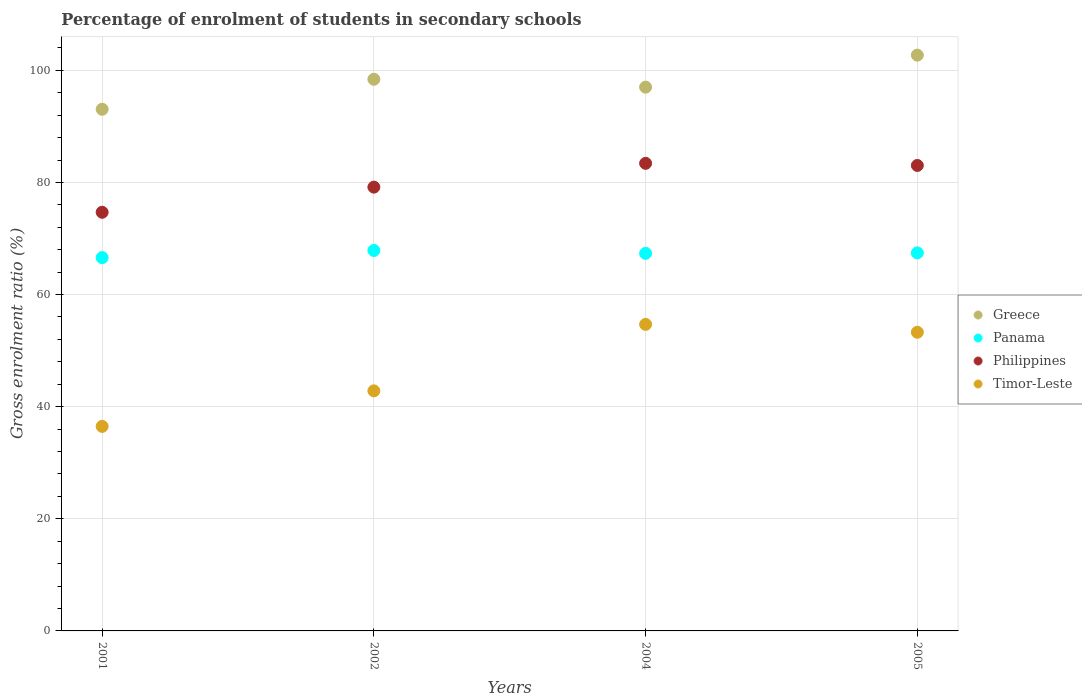What is the percentage of students enrolled in secondary schools in Greece in 2004?
Give a very brief answer. 97. Across all years, what is the maximum percentage of students enrolled in secondary schools in Timor-Leste?
Provide a succinct answer. 54.68. Across all years, what is the minimum percentage of students enrolled in secondary schools in Philippines?
Offer a terse response. 74.68. What is the total percentage of students enrolled in secondary schools in Philippines in the graph?
Offer a very short reply. 320.27. What is the difference between the percentage of students enrolled in secondary schools in Panama in 2001 and that in 2002?
Offer a terse response. -1.27. What is the difference between the percentage of students enrolled in secondary schools in Panama in 2002 and the percentage of students enrolled in secondary schools in Philippines in 2005?
Make the answer very short. -15.17. What is the average percentage of students enrolled in secondary schools in Panama per year?
Offer a very short reply. 67.31. In the year 2002, what is the difference between the percentage of students enrolled in secondary schools in Timor-Leste and percentage of students enrolled in secondary schools in Philippines?
Your answer should be compact. -36.34. In how many years, is the percentage of students enrolled in secondary schools in Greece greater than 96 %?
Your response must be concise. 3. What is the ratio of the percentage of students enrolled in secondary schools in Panama in 2002 to that in 2005?
Ensure brevity in your answer.  1.01. Is the percentage of students enrolled in secondary schools in Philippines in 2001 less than that in 2002?
Offer a very short reply. Yes. Is the difference between the percentage of students enrolled in secondary schools in Timor-Leste in 2001 and 2002 greater than the difference between the percentage of students enrolled in secondary schools in Philippines in 2001 and 2002?
Your answer should be very brief. No. What is the difference between the highest and the second highest percentage of students enrolled in secondary schools in Panama?
Offer a terse response. 0.43. What is the difference between the highest and the lowest percentage of students enrolled in secondary schools in Panama?
Your answer should be compact. 1.27. Is the sum of the percentage of students enrolled in secondary schools in Timor-Leste in 2002 and 2005 greater than the maximum percentage of students enrolled in secondary schools in Panama across all years?
Ensure brevity in your answer.  Yes. Is it the case that in every year, the sum of the percentage of students enrolled in secondary schools in Timor-Leste and percentage of students enrolled in secondary schools in Panama  is greater than the sum of percentage of students enrolled in secondary schools in Greece and percentage of students enrolled in secondary schools in Philippines?
Make the answer very short. No. Does the percentage of students enrolled in secondary schools in Greece monotonically increase over the years?
Provide a short and direct response. No. Is the percentage of students enrolled in secondary schools in Philippines strictly less than the percentage of students enrolled in secondary schools in Panama over the years?
Make the answer very short. No. How many years are there in the graph?
Make the answer very short. 4. Are the values on the major ticks of Y-axis written in scientific E-notation?
Make the answer very short. No. How many legend labels are there?
Keep it short and to the point. 4. How are the legend labels stacked?
Keep it short and to the point. Vertical. What is the title of the graph?
Your answer should be compact. Percentage of enrolment of students in secondary schools. What is the label or title of the X-axis?
Your response must be concise. Years. What is the Gross enrolment ratio (%) of Greece in 2001?
Keep it short and to the point. 93.05. What is the Gross enrolment ratio (%) in Panama in 2001?
Provide a succinct answer. 66.59. What is the Gross enrolment ratio (%) in Philippines in 2001?
Provide a short and direct response. 74.68. What is the Gross enrolment ratio (%) of Timor-Leste in 2001?
Make the answer very short. 36.48. What is the Gross enrolment ratio (%) in Greece in 2002?
Offer a very short reply. 98.4. What is the Gross enrolment ratio (%) in Panama in 2002?
Provide a short and direct response. 67.86. What is the Gross enrolment ratio (%) of Philippines in 2002?
Ensure brevity in your answer.  79.16. What is the Gross enrolment ratio (%) of Timor-Leste in 2002?
Your response must be concise. 42.82. What is the Gross enrolment ratio (%) of Greece in 2004?
Your answer should be very brief. 97. What is the Gross enrolment ratio (%) in Panama in 2004?
Your response must be concise. 67.35. What is the Gross enrolment ratio (%) of Philippines in 2004?
Provide a short and direct response. 83.41. What is the Gross enrolment ratio (%) in Timor-Leste in 2004?
Your response must be concise. 54.68. What is the Gross enrolment ratio (%) of Greece in 2005?
Offer a very short reply. 102.71. What is the Gross enrolment ratio (%) in Panama in 2005?
Offer a very short reply. 67.43. What is the Gross enrolment ratio (%) of Philippines in 2005?
Ensure brevity in your answer.  83.03. What is the Gross enrolment ratio (%) of Timor-Leste in 2005?
Provide a succinct answer. 53.27. Across all years, what is the maximum Gross enrolment ratio (%) in Greece?
Make the answer very short. 102.71. Across all years, what is the maximum Gross enrolment ratio (%) in Panama?
Provide a short and direct response. 67.86. Across all years, what is the maximum Gross enrolment ratio (%) in Philippines?
Provide a succinct answer. 83.41. Across all years, what is the maximum Gross enrolment ratio (%) of Timor-Leste?
Offer a terse response. 54.68. Across all years, what is the minimum Gross enrolment ratio (%) of Greece?
Offer a very short reply. 93.05. Across all years, what is the minimum Gross enrolment ratio (%) in Panama?
Make the answer very short. 66.59. Across all years, what is the minimum Gross enrolment ratio (%) of Philippines?
Make the answer very short. 74.68. Across all years, what is the minimum Gross enrolment ratio (%) of Timor-Leste?
Your answer should be compact. 36.48. What is the total Gross enrolment ratio (%) of Greece in the graph?
Your answer should be very brief. 391.15. What is the total Gross enrolment ratio (%) of Panama in the graph?
Your answer should be compact. 269.23. What is the total Gross enrolment ratio (%) in Philippines in the graph?
Offer a terse response. 320.27. What is the total Gross enrolment ratio (%) in Timor-Leste in the graph?
Keep it short and to the point. 187.25. What is the difference between the Gross enrolment ratio (%) in Greece in 2001 and that in 2002?
Provide a short and direct response. -5.35. What is the difference between the Gross enrolment ratio (%) of Panama in 2001 and that in 2002?
Offer a very short reply. -1.27. What is the difference between the Gross enrolment ratio (%) of Philippines in 2001 and that in 2002?
Give a very brief answer. -4.48. What is the difference between the Gross enrolment ratio (%) in Timor-Leste in 2001 and that in 2002?
Your answer should be compact. -6.34. What is the difference between the Gross enrolment ratio (%) in Greece in 2001 and that in 2004?
Ensure brevity in your answer.  -3.95. What is the difference between the Gross enrolment ratio (%) of Panama in 2001 and that in 2004?
Make the answer very short. -0.76. What is the difference between the Gross enrolment ratio (%) in Philippines in 2001 and that in 2004?
Provide a succinct answer. -8.73. What is the difference between the Gross enrolment ratio (%) of Timor-Leste in 2001 and that in 2004?
Offer a very short reply. -18.2. What is the difference between the Gross enrolment ratio (%) of Greece in 2001 and that in 2005?
Provide a short and direct response. -9.66. What is the difference between the Gross enrolment ratio (%) in Panama in 2001 and that in 2005?
Offer a terse response. -0.84. What is the difference between the Gross enrolment ratio (%) in Philippines in 2001 and that in 2005?
Your answer should be very brief. -8.35. What is the difference between the Gross enrolment ratio (%) in Timor-Leste in 2001 and that in 2005?
Offer a very short reply. -16.79. What is the difference between the Gross enrolment ratio (%) of Greece in 2002 and that in 2004?
Keep it short and to the point. 1.41. What is the difference between the Gross enrolment ratio (%) of Panama in 2002 and that in 2004?
Your answer should be very brief. 0.51. What is the difference between the Gross enrolment ratio (%) in Philippines in 2002 and that in 2004?
Ensure brevity in your answer.  -4.25. What is the difference between the Gross enrolment ratio (%) of Timor-Leste in 2002 and that in 2004?
Provide a short and direct response. -11.86. What is the difference between the Gross enrolment ratio (%) in Greece in 2002 and that in 2005?
Keep it short and to the point. -4.3. What is the difference between the Gross enrolment ratio (%) in Panama in 2002 and that in 2005?
Offer a very short reply. 0.43. What is the difference between the Gross enrolment ratio (%) in Philippines in 2002 and that in 2005?
Offer a terse response. -3.87. What is the difference between the Gross enrolment ratio (%) in Timor-Leste in 2002 and that in 2005?
Offer a very short reply. -10.45. What is the difference between the Gross enrolment ratio (%) of Greece in 2004 and that in 2005?
Your answer should be compact. -5.71. What is the difference between the Gross enrolment ratio (%) of Panama in 2004 and that in 2005?
Give a very brief answer. -0.08. What is the difference between the Gross enrolment ratio (%) in Philippines in 2004 and that in 2005?
Offer a terse response. 0.38. What is the difference between the Gross enrolment ratio (%) of Timor-Leste in 2004 and that in 2005?
Ensure brevity in your answer.  1.41. What is the difference between the Gross enrolment ratio (%) in Greece in 2001 and the Gross enrolment ratio (%) in Panama in 2002?
Provide a succinct answer. 25.19. What is the difference between the Gross enrolment ratio (%) of Greece in 2001 and the Gross enrolment ratio (%) of Philippines in 2002?
Ensure brevity in your answer.  13.89. What is the difference between the Gross enrolment ratio (%) of Greece in 2001 and the Gross enrolment ratio (%) of Timor-Leste in 2002?
Provide a succinct answer. 50.23. What is the difference between the Gross enrolment ratio (%) in Panama in 2001 and the Gross enrolment ratio (%) in Philippines in 2002?
Your answer should be very brief. -12.57. What is the difference between the Gross enrolment ratio (%) in Panama in 2001 and the Gross enrolment ratio (%) in Timor-Leste in 2002?
Provide a succinct answer. 23.77. What is the difference between the Gross enrolment ratio (%) of Philippines in 2001 and the Gross enrolment ratio (%) of Timor-Leste in 2002?
Give a very brief answer. 31.86. What is the difference between the Gross enrolment ratio (%) of Greece in 2001 and the Gross enrolment ratio (%) of Panama in 2004?
Offer a very short reply. 25.7. What is the difference between the Gross enrolment ratio (%) of Greece in 2001 and the Gross enrolment ratio (%) of Philippines in 2004?
Offer a very short reply. 9.64. What is the difference between the Gross enrolment ratio (%) of Greece in 2001 and the Gross enrolment ratio (%) of Timor-Leste in 2004?
Provide a short and direct response. 38.37. What is the difference between the Gross enrolment ratio (%) in Panama in 2001 and the Gross enrolment ratio (%) in Philippines in 2004?
Provide a succinct answer. -16.82. What is the difference between the Gross enrolment ratio (%) of Panama in 2001 and the Gross enrolment ratio (%) of Timor-Leste in 2004?
Your response must be concise. 11.91. What is the difference between the Gross enrolment ratio (%) in Philippines in 2001 and the Gross enrolment ratio (%) in Timor-Leste in 2004?
Offer a very short reply. 20. What is the difference between the Gross enrolment ratio (%) of Greece in 2001 and the Gross enrolment ratio (%) of Panama in 2005?
Ensure brevity in your answer.  25.61. What is the difference between the Gross enrolment ratio (%) in Greece in 2001 and the Gross enrolment ratio (%) in Philippines in 2005?
Ensure brevity in your answer.  10.02. What is the difference between the Gross enrolment ratio (%) in Greece in 2001 and the Gross enrolment ratio (%) in Timor-Leste in 2005?
Make the answer very short. 39.78. What is the difference between the Gross enrolment ratio (%) of Panama in 2001 and the Gross enrolment ratio (%) of Philippines in 2005?
Offer a terse response. -16.44. What is the difference between the Gross enrolment ratio (%) of Panama in 2001 and the Gross enrolment ratio (%) of Timor-Leste in 2005?
Your answer should be compact. 13.32. What is the difference between the Gross enrolment ratio (%) of Philippines in 2001 and the Gross enrolment ratio (%) of Timor-Leste in 2005?
Provide a succinct answer. 21.41. What is the difference between the Gross enrolment ratio (%) of Greece in 2002 and the Gross enrolment ratio (%) of Panama in 2004?
Your answer should be compact. 31.05. What is the difference between the Gross enrolment ratio (%) of Greece in 2002 and the Gross enrolment ratio (%) of Philippines in 2004?
Keep it short and to the point. 14.99. What is the difference between the Gross enrolment ratio (%) of Greece in 2002 and the Gross enrolment ratio (%) of Timor-Leste in 2004?
Offer a terse response. 43.72. What is the difference between the Gross enrolment ratio (%) of Panama in 2002 and the Gross enrolment ratio (%) of Philippines in 2004?
Your response must be concise. -15.55. What is the difference between the Gross enrolment ratio (%) in Panama in 2002 and the Gross enrolment ratio (%) in Timor-Leste in 2004?
Make the answer very short. 13.18. What is the difference between the Gross enrolment ratio (%) in Philippines in 2002 and the Gross enrolment ratio (%) in Timor-Leste in 2004?
Offer a terse response. 24.48. What is the difference between the Gross enrolment ratio (%) in Greece in 2002 and the Gross enrolment ratio (%) in Panama in 2005?
Your response must be concise. 30.97. What is the difference between the Gross enrolment ratio (%) in Greece in 2002 and the Gross enrolment ratio (%) in Philippines in 2005?
Your answer should be compact. 15.37. What is the difference between the Gross enrolment ratio (%) of Greece in 2002 and the Gross enrolment ratio (%) of Timor-Leste in 2005?
Provide a short and direct response. 45.13. What is the difference between the Gross enrolment ratio (%) of Panama in 2002 and the Gross enrolment ratio (%) of Philippines in 2005?
Offer a terse response. -15.17. What is the difference between the Gross enrolment ratio (%) of Panama in 2002 and the Gross enrolment ratio (%) of Timor-Leste in 2005?
Your response must be concise. 14.59. What is the difference between the Gross enrolment ratio (%) of Philippines in 2002 and the Gross enrolment ratio (%) of Timor-Leste in 2005?
Your response must be concise. 25.89. What is the difference between the Gross enrolment ratio (%) of Greece in 2004 and the Gross enrolment ratio (%) of Panama in 2005?
Ensure brevity in your answer.  29.56. What is the difference between the Gross enrolment ratio (%) in Greece in 2004 and the Gross enrolment ratio (%) in Philippines in 2005?
Make the answer very short. 13.97. What is the difference between the Gross enrolment ratio (%) of Greece in 2004 and the Gross enrolment ratio (%) of Timor-Leste in 2005?
Give a very brief answer. 43.72. What is the difference between the Gross enrolment ratio (%) in Panama in 2004 and the Gross enrolment ratio (%) in Philippines in 2005?
Your response must be concise. -15.68. What is the difference between the Gross enrolment ratio (%) of Panama in 2004 and the Gross enrolment ratio (%) of Timor-Leste in 2005?
Ensure brevity in your answer.  14.08. What is the difference between the Gross enrolment ratio (%) in Philippines in 2004 and the Gross enrolment ratio (%) in Timor-Leste in 2005?
Provide a succinct answer. 30.14. What is the average Gross enrolment ratio (%) in Greece per year?
Make the answer very short. 97.79. What is the average Gross enrolment ratio (%) in Panama per year?
Give a very brief answer. 67.31. What is the average Gross enrolment ratio (%) in Philippines per year?
Ensure brevity in your answer.  80.07. What is the average Gross enrolment ratio (%) in Timor-Leste per year?
Ensure brevity in your answer.  46.81. In the year 2001, what is the difference between the Gross enrolment ratio (%) of Greece and Gross enrolment ratio (%) of Panama?
Your answer should be very brief. 26.46. In the year 2001, what is the difference between the Gross enrolment ratio (%) of Greece and Gross enrolment ratio (%) of Philippines?
Ensure brevity in your answer.  18.37. In the year 2001, what is the difference between the Gross enrolment ratio (%) in Greece and Gross enrolment ratio (%) in Timor-Leste?
Provide a short and direct response. 56.57. In the year 2001, what is the difference between the Gross enrolment ratio (%) of Panama and Gross enrolment ratio (%) of Philippines?
Provide a succinct answer. -8.09. In the year 2001, what is the difference between the Gross enrolment ratio (%) in Panama and Gross enrolment ratio (%) in Timor-Leste?
Offer a terse response. 30.11. In the year 2001, what is the difference between the Gross enrolment ratio (%) of Philippines and Gross enrolment ratio (%) of Timor-Leste?
Your response must be concise. 38.19. In the year 2002, what is the difference between the Gross enrolment ratio (%) of Greece and Gross enrolment ratio (%) of Panama?
Offer a terse response. 30.54. In the year 2002, what is the difference between the Gross enrolment ratio (%) in Greece and Gross enrolment ratio (%) in Philippines?
Provide a short and direct response. 19.24. In the year 2002, what is the difference between the Gross enrolment ratio (%) in Greece and Gross enrolment ratio (%) in Timor-Leste?
Offer a terse response. 55.58. In the year 2002, what is the difference between the Gross enrolment ratio (%) in Panama and Gross enrolment ratio (%) in Philippines?
Provide a succinct answer. -11.3. In the year 2002, what is the difference between the Gross enrolment ratio (%) of Panama and Gross enrolment ratio (%) of Timor-Leste?
Provide a short and direct response. 25.04. In the year 2002, what is the difference between the Gross enrolment ratio (%) in Philippines and Gross enrolment ratio (%) in Timor-Leste?
Ensure brevity in your answer.  36.34. In the year 2004, what is the difference between the Gross enrolment ratio (%) of Greece and Gross enrolment ratio (%) of Panama?
Provide a short and direct response. 29.65. In the year 2004, what is the difference between the Gross enrolment ratio (%) of Greece and Gross enrolment ratio (%) of Philippines?
Offer a terse response. 13.59. In the year 2004, what is the difference between the Gross enrolment ratio (%) of Greece and Gross enrolment ratio (%) of Timor-Leste?
Your response must be concise. 42.32. In the year 2004, what is the difference between the Gross enrolment ratio (%) in Panama and Gross enrolment ratio (%) in Philippines?
Give a very brief answer. -16.06. In the year 2004, what is the difference between the Gross enrolment ratio (%) of Panama and Gross enrolment ratio (%) of Timor-Leste?
Keep it short and to the point. 12.67. In the year 2004, what is the difference between the Gross enrolment ratio (%) in Philippines and Gross enrolment ratio (%) in Timor-Leste?
Ensure brevity in your answer.  28.73. In the year 2005, what is the difference between the Gross enrolment ratio (%) in Greece and Gross enrolment ratio (%) in Panama?
Keep it short and to the point. 35.27. In the year 2005, what is the difference between the Gross enrolment ratio (%) in Greece and Gross enrolment ratio (%) in Philippines?
Give a very brief answer. 19.68. In the year 2005, what is the difference between the Gross enrolment ratio (%) of Greece and Gross enrolment ratio (%) of Timor-Leste?
Make the answer very short. 49.43. In the year 2005, what is the difference between the Gross enrolment ratio (%) in Panama and Gross enrolment ratio (%) in Philippines?
Offer a terse response. -15.59. In the year 2005, what is the difference between the Gross enrolment ratio (%) in Panama and Gross enrolment ratio (%) in Timor-Leste?
Your response must be concise. 14.16. In the year 2005, what is the difference between the Gross enrolment ratio (%) in Philippines and Gross enrolment ratio (%) in Timor-Leste?
Provide a succinct answer. 29.76. What is the ratio of the Gross enrolment ratio (%) in Greece in 2001 to that in 2002?
Make the answer very short. 0.95. What is the ratio of the Gross enrolment ratio (%) in Panama in 2001 to that in 2002?
Offer a terse response. 0.98. What is the ratio of the Gross enrolment ratio (%) in Philippines in 2001 to that in 2002?
Provide a short and direct response. 0.94. What is the ratio of the Gross enrolment ratio (%) in Timor-Leste in 2001 to that in 2002?
Your answer should be compact. 0.85. What is the ratio of the Gross enrolment ratio (%) of Greece in 2001 to that in 2004?
Offer a terse response. 0.96. What is the ratio of the Gross enrolment ratio (%) of Panama in 2001 to that in 2004?
Keep it short and to the point. 0.99. What is the ratio of the Gross enrolment ratio (%) in Philippines in 2001 to that in 2004?
Make the answer very short. 0.9. What is the ratio of the Gross enrolment ratio (%) of Timor-Leste in 2001 to that in 2004?
Provide a short and direct response. 0.67. What is the ratio of the Gross enrolment ratio (%) in Greece in 2001 to that in 2005?
Ensure brevity in your answer.  0.91. What is the ratio of the Gross enrolment ratio (%) in Panama in 2001 to that in 2005?
Provide a short and direct response. 0.99. What is the ratio of the Gross enrolment ratio (%) in Philippines in 2001 to that in 2005?
Offer a terse response. 0.9. What is the ratio of the Gross enrolment ratio (%) in Timor-Leste in 2001 to that in 2005?
Offer a terse response. 0.68. What is the ratio of the Gross enrolment ratio (%) in Greece in 2002 to that in 2004?
Give a very brief answer. 1.01. What is the ratio of the Gross enrolment ratio (%) of Panama in 2002 to that in 2004?
Make the answer very short. 1.01. What is the ratio of the Gross enrolment ratio (%) in Philippines in 2002 to that in 2004?
Provide a short and direct response. 0.95. What is the ratio of the Gross enrolment ratio (%) of Timor-Leste in 2002 to that in 2004?
Your response must be concise. 0.78. What is the ratio of the Gross enrolment ratio (%) of Greece in 2002 to that in 2005?
Make the answer very short. 0.96. What is the ratio of the Gross enrolment ratio (%) in Philippines in 2002 to that in 2005?
Give a very brief answer. 0.95. What is the ratio of the Gross enrolment ratio (%) in Timor-Leste in 2002 to that in 2005?
Your answer should be compact. 0.8. What is the ratio of the Gross enrolment ratio (%) of Timor-Leste in 2004 to that in 2005?
Give a very brief answer. 1.03. What is the difference between the highest and the second highest Gross enrolment ratio (%) of Greece?
Your response must be concise. 4.3. What is the difference between the highest and the second highest Gross enrolment ratio (%) in Panama?
Your response must be concise. 0.43. What is the difference between the highest and the second highest Gross enrolment ratio (%) of Philippines?
Provide a succinct answer. 0.38. What is the difference between the highest and the second highest Gross enrolment ratio (%) in Timor-Leste?
Give a very brief answer. 1.41. What is the difference between the highest and the lowest Gross enrolment ratio (%) of Greece?
Provide a succinct answer. 9.66. What is the difference between the highest and the lowest Gross enrolment ratio (%) of Panama?
Give a very brief answer. 1.27. What is the difference between the highest and the lowest Gross enrolment ratio (%) of Philippines?
Make the answer very short. 8.73. What is the difference between the highest and the lowest Gross enrolment ratio (%) in Timor-Leste?
Provide a short and direct response. 18.2. 